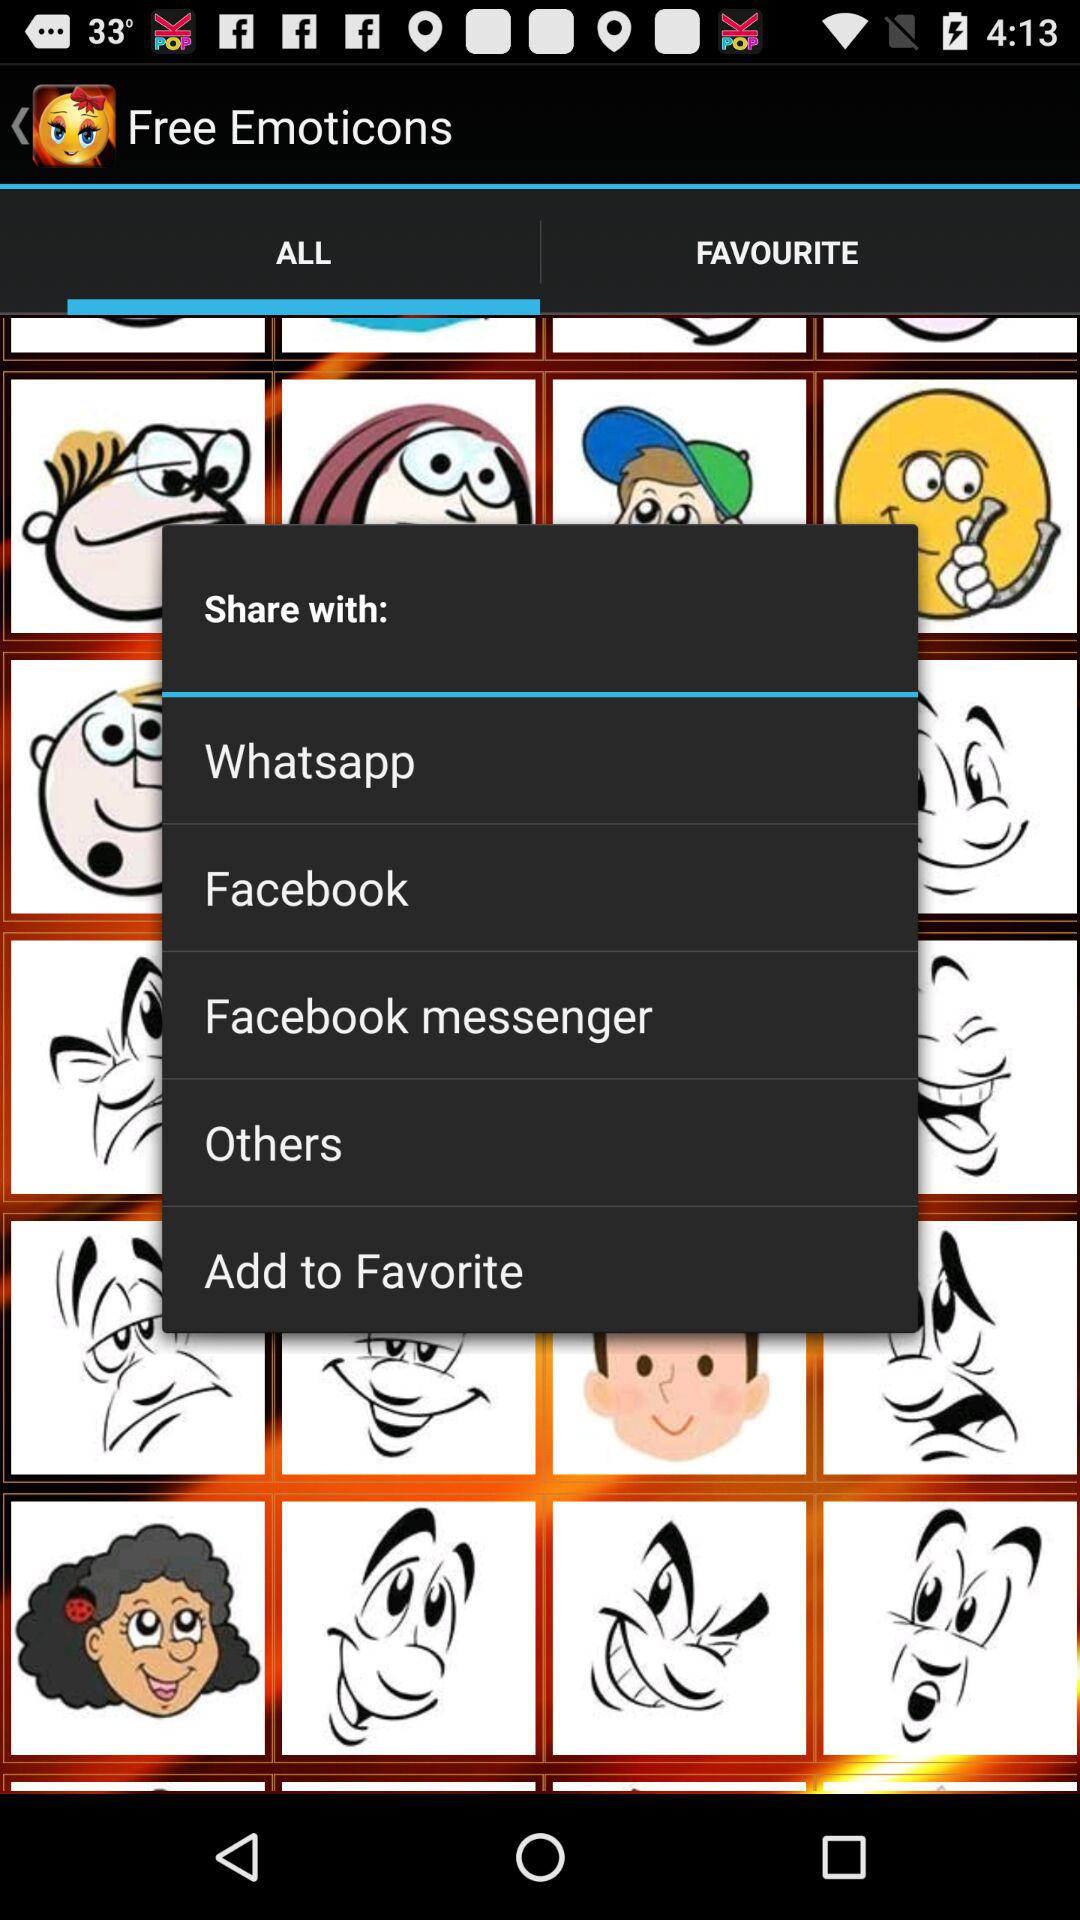What application can I use to share? You can use "Whatsapp", "Facebook" and "Facebook messenger" to share. 